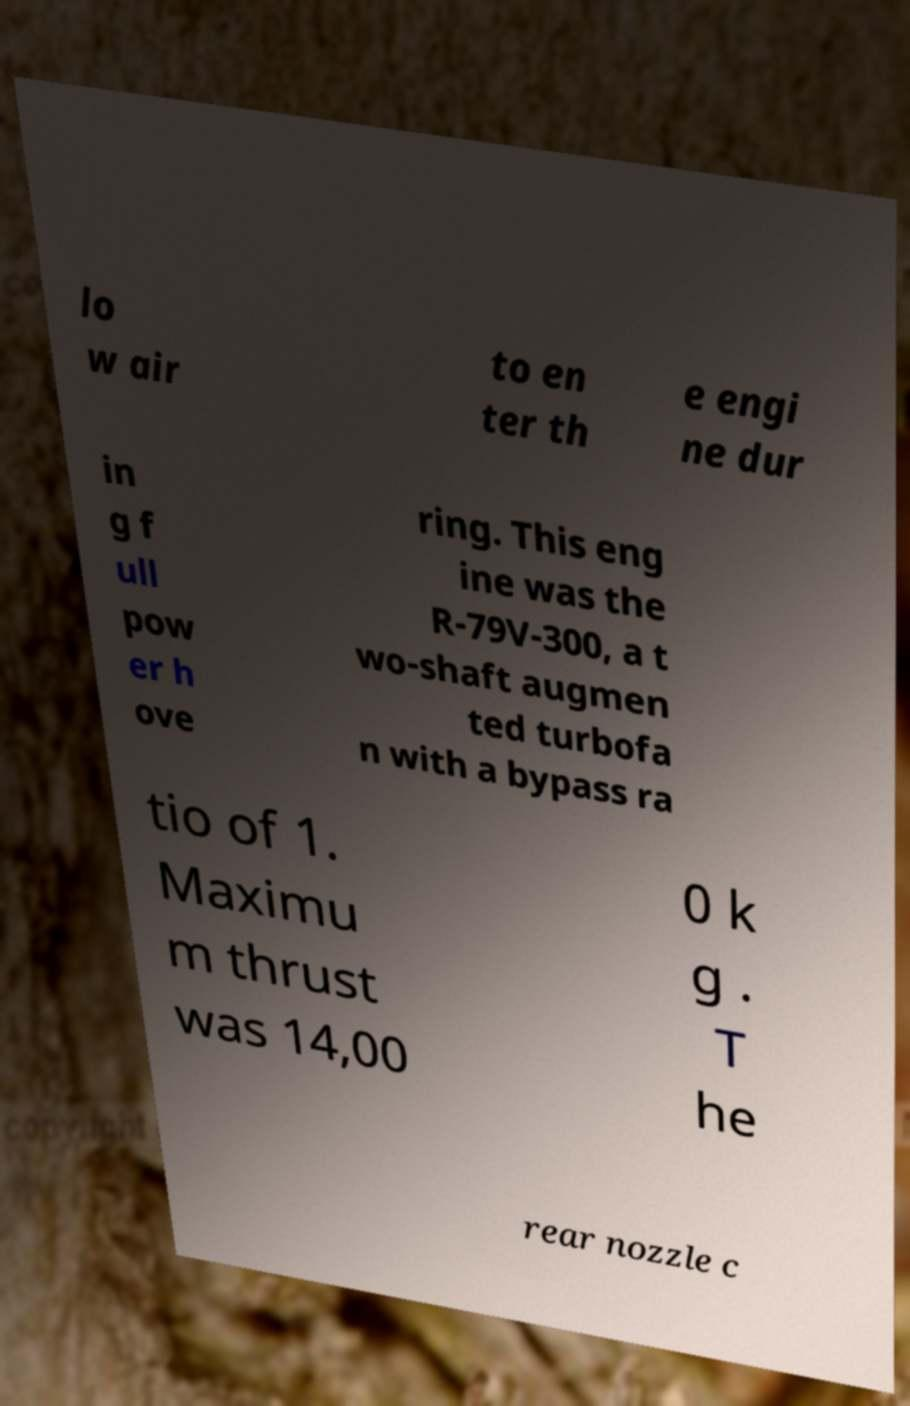For documentation purposes, I need the text within this image transcribed. Could you provide that? lo w air to en ter th e engi ne dur in g f ull pow er h ove ring. This eng ine was the R-79V-300, a t wo-shaft augmen ted turbofa n with a bypass ra tio of 1. Maximu m thrust was 14,00 0 k g . T he rear nozzle c 